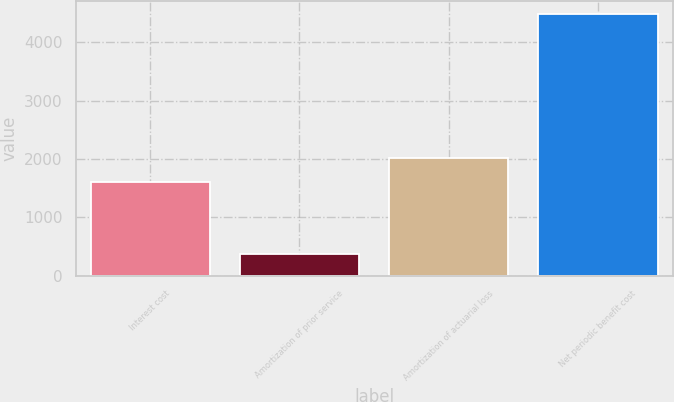Convert chart. <chart><loc_0><loc_0><loc_500><loc_500><bar_chart><fcel>Interest cost<fcel>Amortization of prior service<fcel>Amortization of actuarial loss<fcel>Net periodic benefit cost<nl><fcel>1614<fcel>371<fcel>2025<fcel>4481<nl></chart> 